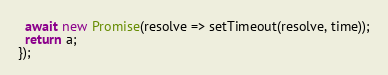<code> <loc_0><loc_0><loc_500><loc_500><_JavaScript_>  await new Promise(resolve => setTimeout(resolve, time));
  return a;
});</code> 